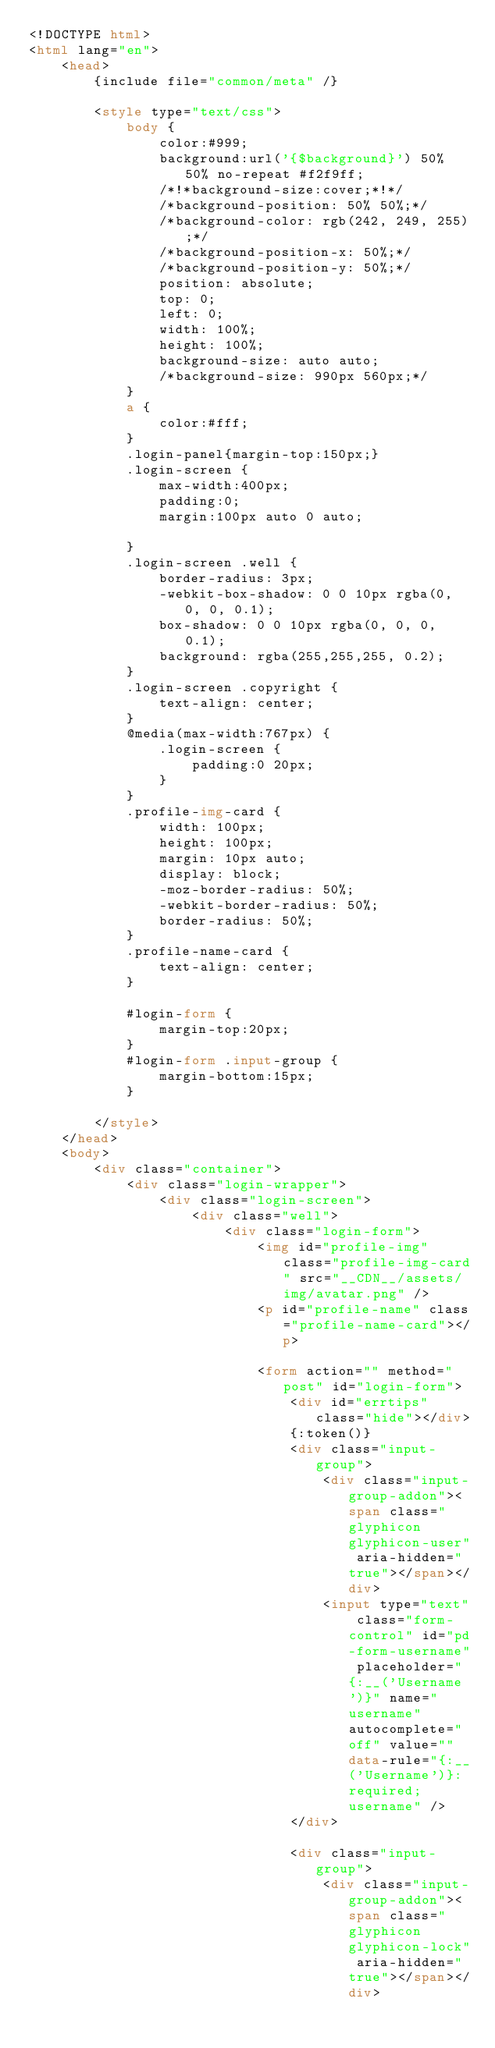Convert code to text. <code><loc_0><loc_0><loc_500><loc_500><_HTML_><!DOCTYPE html>
<html lang="en">
    <head>
        {include file="common/meta" /}

        <style type="text/css">
            body {
                color:#999;
                background:url('{$background}') 50% 50% no-repeat #f2f9ff;
                /*!*background-size:cover;*!*/
                /*background-position: 50% 50%;*/
                /*background-color: rgb(242, 249, 255);*/
                /*background-position-x: 50%;*/
                /*background-position-y: 50%;*/
                position: absolute;
                top: 0;
                left: 0;
                width: 100%;
                height: 100%;
                background-size: auto auto;
                /*background-size: 990px 560px;*/
            }
            a {
                color:#fff;
            }
            .login-panel{margin-top:150px;}
            .login-screen {
                max-width:400px;
                padding:0;
                margin:100px auto 0 auto;

            }
            .login-screen .well {
                border-radius: 3px;
                -webkit-box-shadow: 0 0 10px rgba(0, 0, 0, 0.1);
                box-shadow: 0 0 10px rgba(0, 0, 0, 0.1);
                background: rgba(255,255,255, 0.2);
            }
            .login-screen .copyright {
                text-align: center;
            }
            @media(max-width:767px) {
                .login-screen {
                    padding:0 20px;
                }
            }
            .profile-img-card {
                width: 100px;
                height: 100px;
                margin: 10px auto;
                display: block;
                -moz-border-radius: 50%;
                -webkit-border-radius: 50%;
                border-radius: 50%;
            }
            .profile-name-card {
                text-align: center;
            }

            #login-form {
                margin-top:20px;
            }
            #login-form .input-group {
                margin-bottom:15px;
            }

        </style>
    </head>
    <body>
        <div class="container">
            <div class="login-wrapper">
                <div class="login-screen">
                    <div class="well">
                        <div class="login-form">
                            <img id="profile-img" class="profile-img-card" src="__CDN__/assets/img/avatar.png" />
                            <p id="profile-name" class="profile-name-card"></p>

                            <form action="" method="post" id="login-form">
                                <div id="errtips" class="hide"></div>
                                {:token()}
                                <div class="input-group">
                                    <div class="input-group-addon"><span class="glyphicon glyphicon-user" aria-hidden="true"></span></div>
                                    <input type="text" class="form-control" id="pd-form-username" placeholder="{:__('Username')}" name="username" autocomplete="off" value="" data-rule="{:__('Username')}:required;username" />
                                </div>

                                <div class="input-group">
                                    <div class="input-group-addon"><span class="glyphicon glyphicon-lock" aria-hidden="true"></span></div></code> 